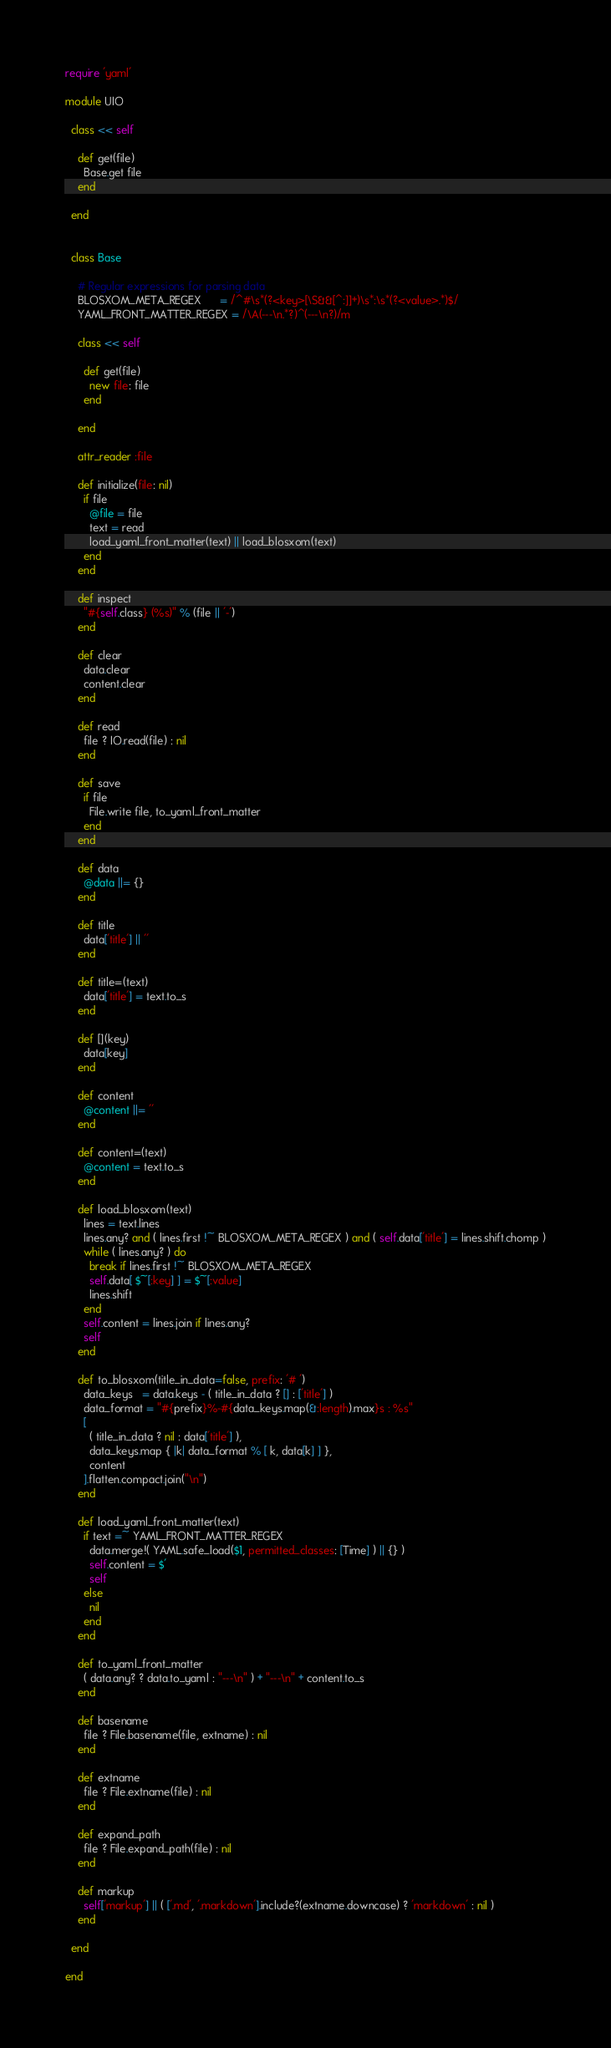Convert code to text. <code><loc_0><loc_0><loc_500><loc_500><_Ruby_>require 'yaml'

module UIO

  class << self

    def get(file)
      Base.get file
    end

  end


  class Base

    # Regular expressions for parsing data
    BLOSXOM_META_REGEX      = /^#\s*(?<key>[\S&&[^:]]+)\s*:\s*(?<value>.*)$/
    YAML_FRONT_MATTER_REGEX = /\A(---\n.*?)^(---\n?)/m

    class << self

      def get(file)
        new file: file
      end

    end

    attr_reader :file

    def initialize(file: nil)
      if file
        @file = file
        text = read
        load_yaml_front_matter(text) || load_blosxom(text)
      end
    end

    def inspect
      "#{self.class} (%s)" % (file || '-')
    end

    def clear
      data.clear
      content.clear
    end

    def read
      file ? IO.read(file) : nil
    end

    def save
      if file
        File.write file, to_yaml_front_matter
      end
    end

    def data
      @data ||= {}
    end

    def title
      data['title'] || ''
    end

    def title=(text)
      data['title'] = text.to_s
    end

    def [](key)
      data[key]
    end

    def content
      @content ||= ''
    end

    def content=(text)
      @content = text.to_s
    end

    def load_blosxom(text)
      lines = text.lines
      lines.any? and ( lines.first !~ BLOSXOM_META_REGEX ) and ( self.data['title'] = lines.shift.chomp )
      while ( lines.any? ) do
        break if lines.first !~ BLOSXOM_META_REGEX
        self.data[ $~[:key] ] = $~[:value]
        lines.shift
      end
      self.content = lines.join if lines.any?
      self
    end

    def to_blosxom(title_in_data=false, prefix: '# ')
      data_keys   = data.keys - ( title_in_data ? [] : ['title'] )
      data_format = "#{prefix}%-#{data_keys.map(&:length).max}s : %s"
      [
        ( title_in_data ? nil : data['title'] ),
        data_keys.map { |k| data_format % [ k, data[k] ] },
        content
      ].flatten.compact.join("\n")
    end

    def load_yaml_front_matter(text)
      if text =~ YAML_FRONT_MATTER_REGEX
        data.merge!( YAML.safe_load($1, permitted_classes: [Time] ) || {} )
        self.content = $'
        self
      else
        nil
      end
    end

    def to_yaml_front_matter
      ( data.any? ? data.to_yaml : "---\n" ) + "---\n" + content.to_s
    end

    def basename
      file ? File.basename(file, extname) : nil
    end

    def extname
      file ? File.extname(file) : nil
    end

    def expand_path
      file ? File.expand_path(file) : nil
    end

    def markup
      self['markup'] || ( ['.md', '.markdown'].include?(extname.downcase) ? 'markdown' : nil )
    end

  end

end
</code> 